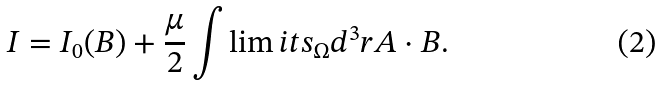Convert formula to latex. <formula><loc_0><loc_0><loc_500><loc_500>I = I _ { 0 } ( { B } ) + \frac { \mu } { 2 } \int \lim i t s _ { \Omega } d ^ { 3 } r A \cdot B .</formula> 